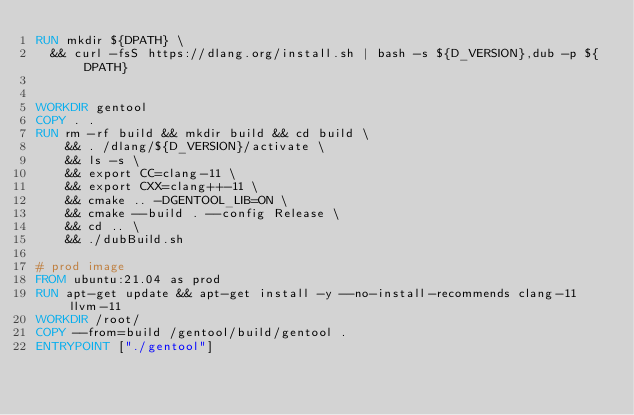<code> <loc_0><loc_0><loc_500><loc_500><_Dockerfile_>RUN mkdir ${DPATH} \
  && curl -fsS https://dlang.org/install.sh | bash -s ${D_VERSION},dub -p ${DPATH}
   

WORKDIR gentool
COPY . .
RUN rm -rf build && mkdir build && cd build \
    && . /dlang/${D_VERSION}/activate \
    && ls -s \
    && export CC=clang-11 \
    && export CXX=clang++-11 \
    && cmake .. -DGENTOOL_LIB=ON \
    && cmake --build . --config Release \
    && cd .. \
    && ./dubBuild.sh

# prod image
FROM ubuntu:21.04 as prod
RUN apt-get update && apt-get install -y --no-install-recommends clang-11 llvm-11
WORKDIR /root/
COPY --from=build /gentool/build/gentool .
ENTRYPOINT ["./gentool"]
</code> 